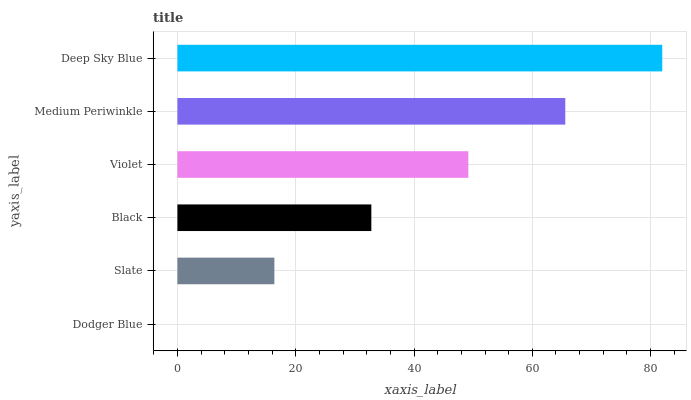Is Dodger Blue the minimum?
Answer yes or no. Yes. Is Deep Sky Blue the maximum?
Answer yes or no. Yes. Is Slate the minimum?
Answer yes or no. No. Is Slate the maximum?
Answer yes or no. No. Is Slate greater than Dodger Blue?
Answer yes or no. Yes. Is Dodger Blue less than Slate?
Answer yes or no. Yes. Is Dodger Blue greater than Slate?
Answer yes or no. No. Is Slate less than Dodger Blue?
Answer yes or no. No. Is Violet the high median?
Answer yes or no. Yes. Is Black the low median?
Answer yes or no. Yes. Is Slate the high median?
Answer yes or no. No. Is Deep Sky Blue the low median?
Answer yes or no. No. 